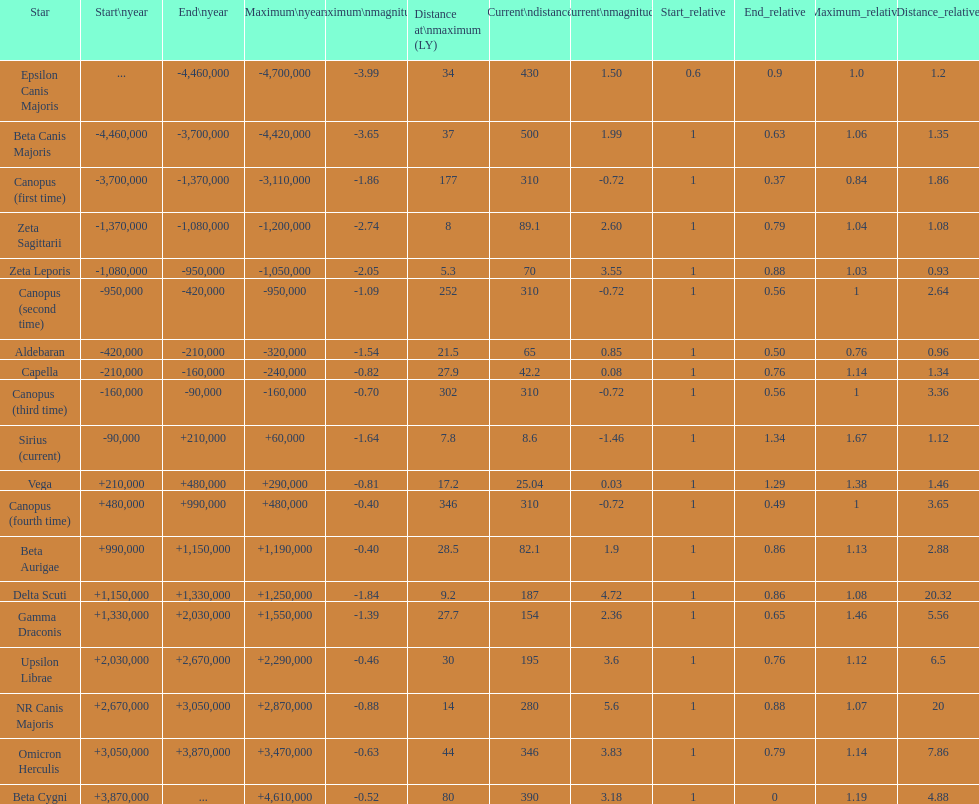How many stars have a distance at maximum of 30 light years or higher? 9. 